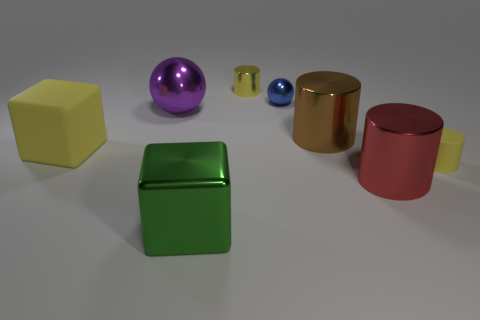Can you describe the positioning of the green cube relative to the other shapes? The green cube is at the forefront of the image, slightly to the left. It's positioned closer to the camera than the other shapes which are arranged both behind it and to its right. Is there anything unique about its surface compared to the others? Yes, the green cube has a slightly reflective surface, which sets it apart from the yellow cube that has a matte finish. 